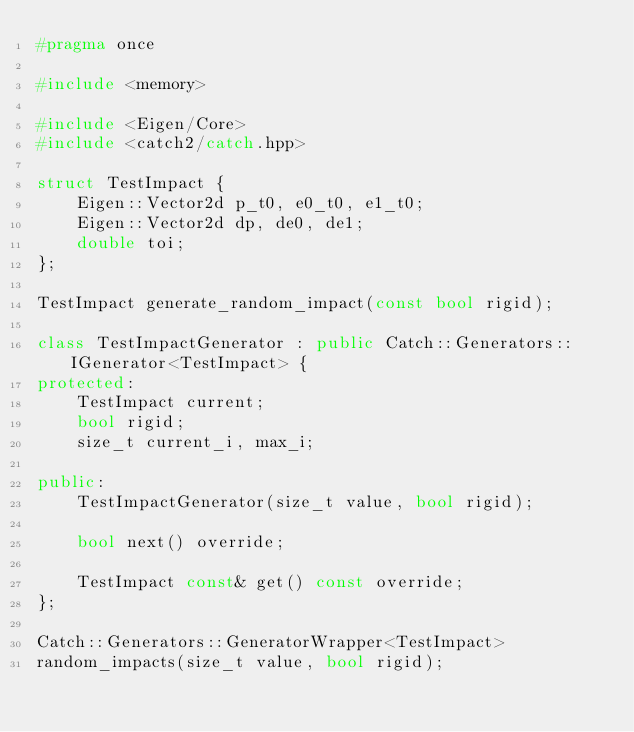Convert code to text. <code><loc_0><loc_0><loc_500><loc_500><_C++_>#pragma once

#include <memory>

#include <Eigen/Core>
#include <catch2/catch.hpp>

struct TestImpact {
    Eigen::Vector2d p_t0, e0_t0, e1_t0;
    Eigen::Vector2d dp, de0, de1;
    double toi;
};

TestImpact generate_random_impact(const bool rigid);

class TestImpactGenerator : public Catch::Generators::IGenerator<TestImpact> {
protected:
    TestImpact current;
    bool rigid;
    size_t current_i, max_i;

public:
    TestImpactGenerator(size_t value, bool rigid);

    bool next() override;

    TestImpact const& get() const override;
};

Catch::Generators::GeneratorWrapper<TestImpact>
random_impacts(size_t value, bool rigid);
</code> 